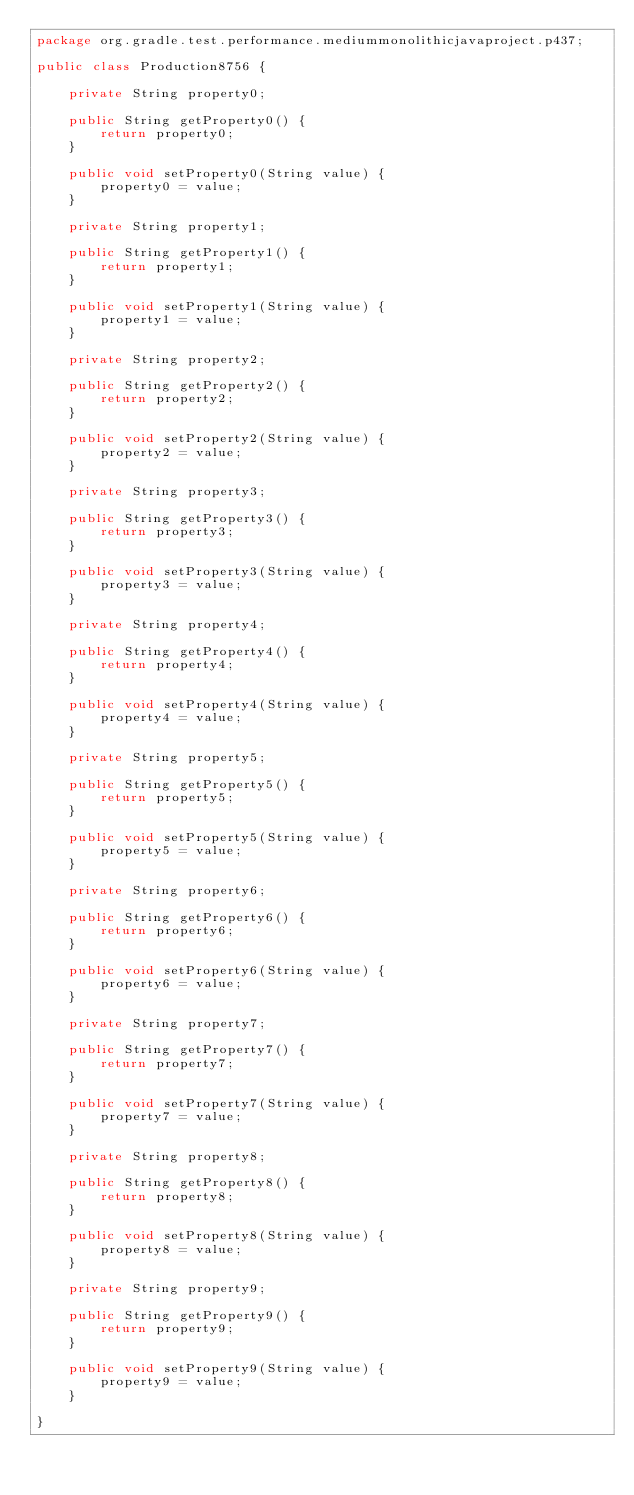Convert code to text. <code><loc_0><loc_0><loc_500><loc_500><_Java_>package org.gradle.test.performance.mediummonolithicjavaproject.p437;

public class Production8756 {        

    private String property0;

    public String getProperty0() {
        return property0;
    }

    public void setProperty0(String value) {
        property0 = value;
    }

    private String property1;

    public String getProperty1() {
        return property1;
    }

    public void setProperty1(String value) {
        property1 = value;
    }

    private String property2;

    public String getProperty2() {
        return property2;
    }

    public void setProperty2(String value) {
        property2 = value;
    }

    private String property3;

    public String getProperty3() {
        return property3;
    }

    public void setProperty3(String value) {
        property3 = value;
    }

    private String property4;

    public String getProperty4() {
        return property4;
    }

    public void setProperty4(String value) {
        property4 = value;
    }

    private String property5;

    public String getProperty5() {
        return property5;
    }

    public void setProperty5(String value) {
        property5 = value;
    }

    private String property6;

    public String getProperty6() {
        return property6;
    }

    public void setProperty6(String value) {
        property6 = value;
    }

    private String property7;

    public String getProperty7() {
        return property7;
    }

    public void setProperty7(String value) {
        property7 = value;
    }

    private String property8;

    public String getProperty8() {
        return property8;
    }

    public void setProperty8(String value) {
        property8 = value;
    }

    private String property9;

    public String getProperty9() {
        return property9;
    }

    public void setProperty9(String value) {
        property9 = value;
    }

}</code> 